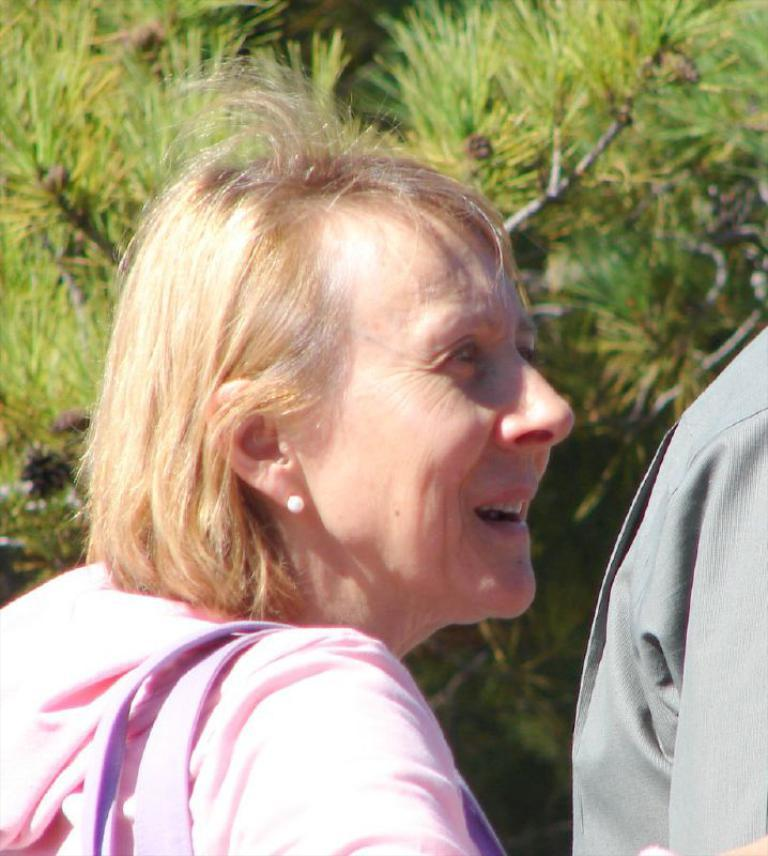Who is present in the image? There is a woman and another human in the image. Can you describe the other human in the image? The other human is on the right side of the image. What can be seen in the background of the image? There is a tree visible in the background of the image. What type of bottle is being used by the woman to answer questions in the image? There is no bottle or questions present in the image; it only features a woman and another human with a tree in the background. 